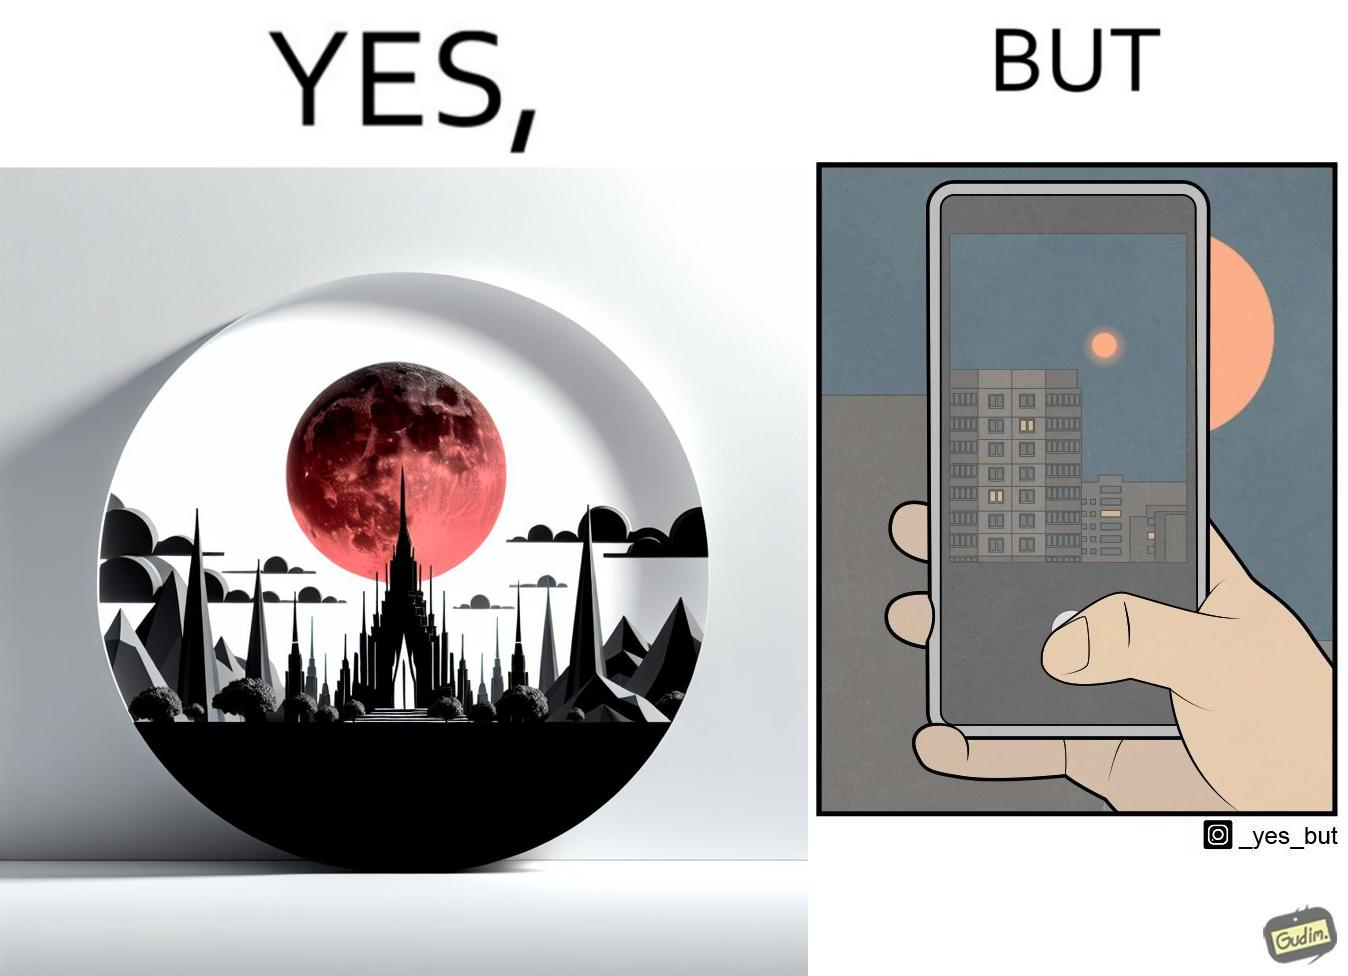Is there satirical content in this image? Yes, this image is satirical. 